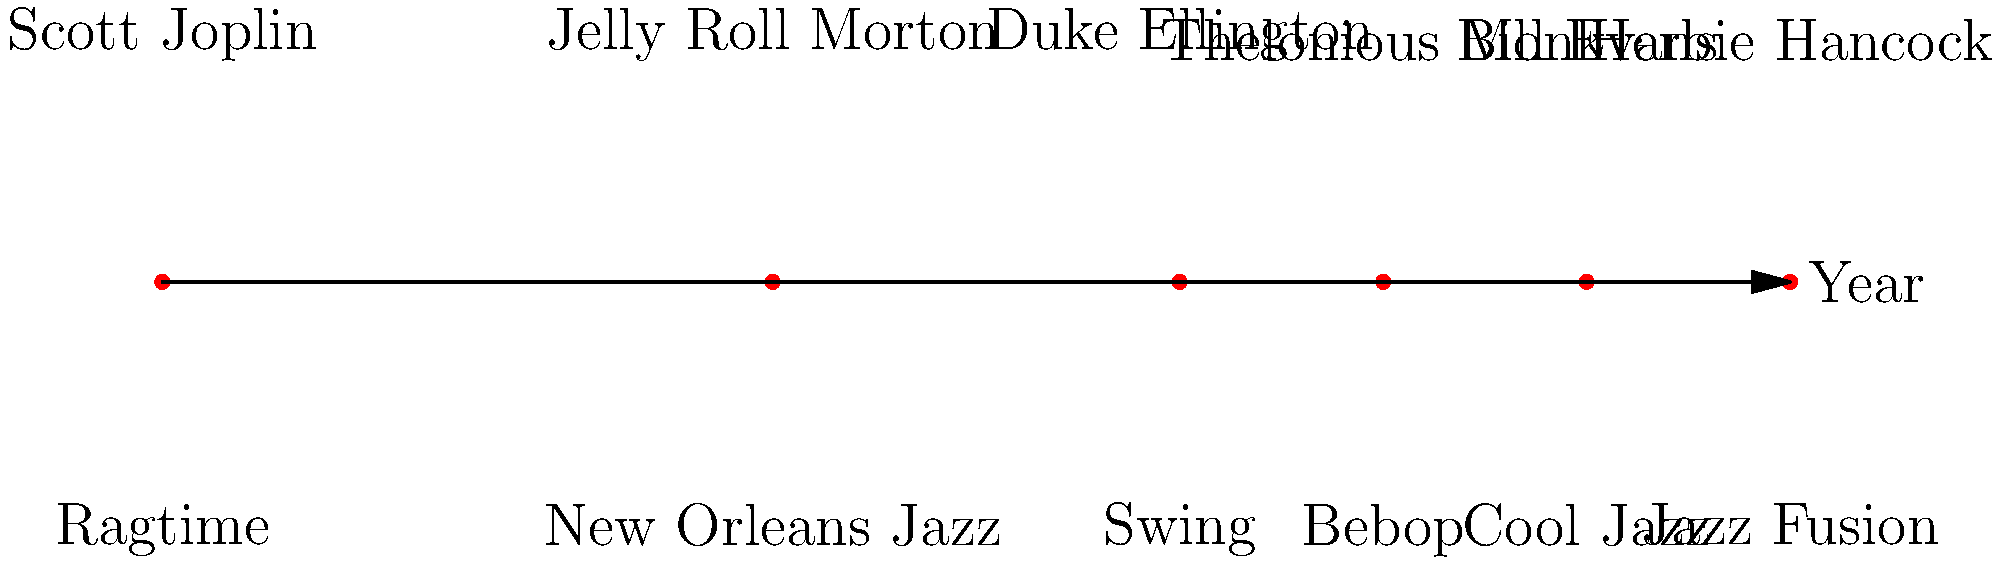Based on the timeline, which jazz genre emerged around 1950 and was associated with pianist Thelonious Monk? To answer this question, let's analyze the timeline step-by-step:

1. The timeline shows the evolution of jazz genres from 1890 to 1970.
2. Each point on the timeline represents a specific genre and an influential pianist associated with it.
3. We need to focus on the period around 1950 and look for Thelonious Monk.
4. Scanning the timeline, we can see:
   - 1890: Ragtime (Scott Joplin)
   - 1920: New Orleans Jazz (Jelly Roll Morton)
   - 1940: Swing (Duke Ellington)
   - 1950: Bebop (Thelonious Monk)
   - 1960: Cool Jazz (Bill Evans)
   - 1970: Jazz Fusion (Herbie Hancock)
5. We can clearly see that around 1950, the genre associated with Thelonious Monk is Bebop.

Therefore, the jazz genre that emerged around 1950 and was associated with pianist Thelonious Monk is Bebop.
Answer: Bebop 